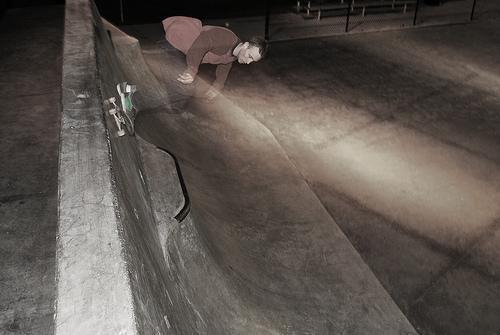How many people are in the photo?
Give a very brief answer. 1. 